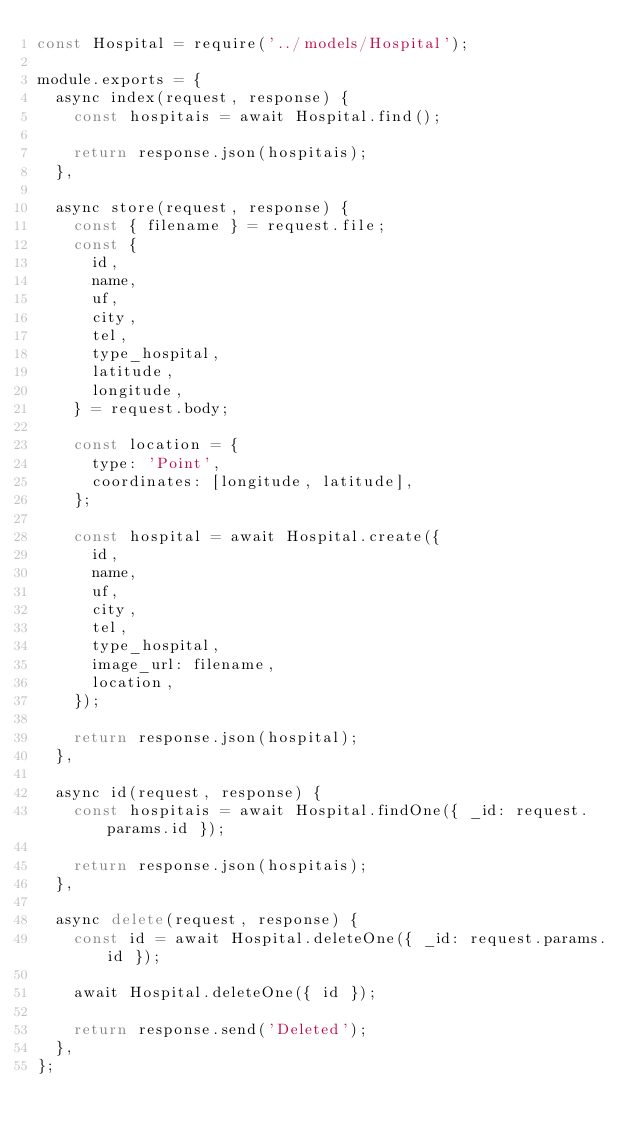<code> <loc_0><loc_0><loc_500><loc_500><_JavaScript_>const Hospital = require('../models/Hospital');

module.exports = {
  async index(request, response) {
    const hospitais = await Hospital.find();

    return response.json(hospitais);
  },

  async store(request, response) {
    const { filename } = request.file;
    const {
      id,
      name,
      uf,
      city,
      tel,
      type_hospital,
      latitude,
      longitude,
    } = request.body;

    const location = {
      type: 'Point',
      coordinates: [longitude, latitude],
    };

    const hospital = await Hospital.create({
      id,
      name,
      uf,
      city,
      tel,
      type_hospital,
      image_url: filename,
      location,
    });

    return response.json(hospital);
  },

  async id(request, response) {
    const hospitais = await Hospital.findOne({ _id: request.params.id });

    return response.json(hospitais);
  },

  async delete(request, response) {
    const id = await Hospital.deleteOne({ _id: request.params.id });

    await Hospital.deleteOne({ id });

    return response.send('Deleted');
  },
};
</code> 